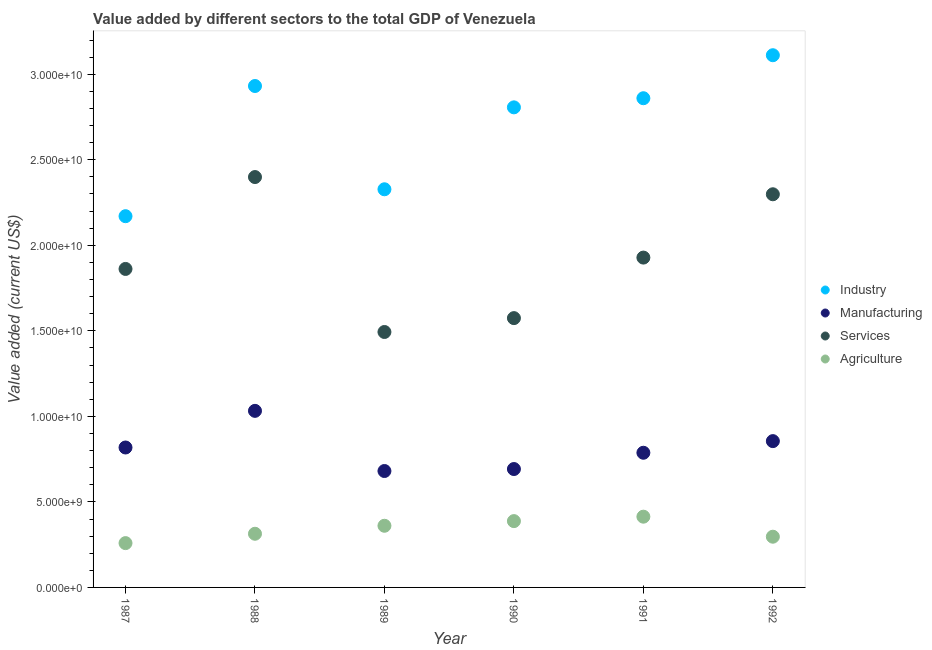How many different coloured dotlines are there?
Keep it short and to the point. 4. Is the number of dotlines equal to the number of legend labels?
Your answer should be very brief. Yes. What is the value added by manufacturing sector in 1992?
Your answer should be very brief. 8.55e+09. Across all years, what is the maximum value added by services sector?
Provide a succinct answer. 2.40e+1. Across all years, what is the minimum value added by industrial sector?
Offer a terse response. 2.17e+1. In which year was the value added by industrial sector maximum?
Ensure brevity in your answer.  1992. In which year was the value added by manufacturing sector minimum?
Keep it short and to the point. 1989. What is the total value added by manufacturing sector in the graph?
Provide a succinct answer. 4.87e+1. What is the difference between the value added by manufacturing sector in 1990 and that in 1992?
Provide a short and direct response. -1.63e+09. What is the difference between the value added by industrial sector in 1989 and the value added by agricultural sector in 1990?
Your answer should be compact. 1.94e+1. What is the average value added by agricultural sector per year?
Offer a terse response. 3.38e+09. In the year 1987, what is the difference between the value added by services sector and value added by agricultural sector?
Provide a succinct answer. 1.60e+1. What is the ratio of the value added by industrial sector in 1989 to that in 1991?
Your answer should be very brief. 0.81. What is the difference between the highest and the second highest value added by agricultural sector?
Provide a succinct answer. 2.59e+08. What is the difference between the highest and the lowest value added by services sector?
Offer a very short reply. 9.06e+09. Is it the case that in every year, the sum of the value added by manufacturing sector and value added by services sector is greater than the sum of value added by agricultural sector and value added by industrial sector?
Make the answer very short. Yes. Is it the case that in every year, the sum of the value added by industrial sector and value added by manufacturing sector is greater than the value added by services sector?
Your answer should be compact. Yes. Does the value added by manufacturing sector monotonically increase over the years?
Offer a terse response. No. Is the value added by services sector strictly greater than the value added by industrial sector over the years?
Keep it short and to the point. No. Are the values on the major ticks of Y-axis written in scientific E-notation?
Give a very brief answer. Yes. Does the graph contain grids?
Give a very brief answer. No. Where does the legend appear in the graph?
Your answer should be very brief. Center right. What is the title of the graph?
Keep it short and to the point. Value added by different sectors to the total GDP of Venezuela. Does "First 20% of population" appear as one of the legend labels in the graph?
Your answer should be compact. No. What is the label or title of the Y-axis?
Offer a very short reply. Value added (current US$). What is the Value added (current US$) in Industry in 1987?
Keep it short and to the point. 2.17e+1. What is the Value added (current US$) in Manufacturing in 1987?
Give a very brief answer. 8.18e+09. What is the Value added (current US$) of Services in 1987?
Your answer should be very brief. 1.86e+1. What is the Value added (current US$) of Agriculture in 1987?
Provide a succinct answer. 2.59e+09. What is the Value added (current US$) of Industry in 1988?
Ensure brevity in your answer.  2.93e+1. What is the Value added (current US$) in Manufacturing in 1988?
Offer a very short reply. 1.03e+1. What is the Value added (current US$) of Services in 1988?
Keep it short and to the point. 2.40e+1. What is the Value added (current US$) in Agriculture in 1988?
Ensure brevity in your answer.  3.14e+09. What is the Value added (current US$) in Industry in 1989?
Offer a very short reply. 2.33e+1. What is the Value added (current US$) in Manufacturing in 1989?
Provide a short and direct response. 6.81e+09. What is the Value added (current US$) in Services in 1989?
Give a very brief answer. 1.49e+1. What is the Value added (current US$) in Agriculture in 1989?
Provide a succinct answer. 3.60e+09. What is the Value added (current US$) in Industry in 1990?
Make the answer very short. 2.81e+1. What is the Value added (current US$) of Manufacturing in 1990?
Offer a very short reply. 6.92e+09. What is the Value added (current US$) in Services in 1990?
Ensure brevity in your answer.  1.57e+1. What is the Value added (current US$) of Agriculture in 1990?
Your answer should be compact. 3.88e+09. What is the Value added (current US$) of Industry in 1991?
Your answer should be compact. 2.86e+1. What is the Value added (current US$) of Manufacturing in 1991?
Provide a short and direct response. 7.87e+09. What is the Value added (current US$) in Services in 1991?
Offer a very short reply. 1.93e+1. What is the Value added (current US$) in Agriculture in 1991?
Provide a short and direct response. 4.14e+09. What is the Value added (current US$) in Industry in 1992?
Your answer should be very brief. 3.11e+1. What is the Value added (current US$) of Manufacturing in 1992?
Offer a very short reply. 8.55e+09. What is the Value added (current US$) in Services in 1992?
Your answer should be very brief. 2.30e+1. What is the Value added (current US$) of Agriculture in 1992?
Your response must be concise. 2.97e+09. Across all years, what is the maximum Value added (current US$) of Industry?
Your answer should be very brief. 3.11e+1. Across all years, what is the maximum Value added (current US$) of Manufacturing?
Your answer should be compact. 1.03e+1. Across all years, what is the maximum Value added (current US$) of Services?
Give a very brief answer. 2.40e+1. Across all years, what is the maximum Value added (current US$) in Agriculture?
Ensure brevity in your answer.  4.14e+09. Across all years, what is the minimum Value added (current US$) in Industry?
Provide a short and direct response. 2.17e+1. Across all years, what is the minimum Value added (current US$) of Manufacturing?
Offer a very short reply. 6.81e+09. Across all years, what is the minimum Value added (current US$) of Services?
Keep it short and to the point. 1.49e+1. Across all years, what is the minimum Value added (current US$) in Agriculture?
Offer a very short reply. 2.59e+09. What is the total Value added (current US$) in Industry in the graph?
Your response must be concise. 1.62e+11. What is the total Value added (current US$) of Manufacturing in the graph?
Your answer should be compact. 4.87e+1. What is the total Value added (current US$) in Services in the graph?
Give a very brief answer. 1.16e+11. What is the total Value added (current US$) of Agriculture in the graph?
Provide a succinct answer. 2.03e+1. What is the difference between the Value added (current US$) in Industry in 1987 and that in 1988?
Provide a short and direct response. -7.61e+09. What is the difference between the Value added (current US$) of Manufacturing in 1987 and that in 1988?
Offer a very short reply. -2.14e+09. What is the difference between the Value added (current US$) of Services in 1987 and that in 1988?
Provide a succinct answer. -5.37e+09. What is the difference between the Value added (current US$) in Agriculture in 1987 and that in 1988?
Your response must be concise. -5.47e+08. What is the difference between the Value added (current US$) of Industry in 1987 and that in 1989?
Your response must be concise. -1.57e+09. What is the difference between the Value added (current US$) in Manufacturing in 1987 and that in 1989?
Ensure brevity in your answer.  1.37e+09. What is the difference between the Value added (current US$) of Services in 1987 and that in 1989?
Provide a short and direct response. 3.69e+09. What is the difference between the Value added (current US$) in Agriculture in 1987 and that in 1989?
Ensure brevity in your answer.  -1.01e+09. What is the difference between the Value added (current US$) of Industry in 1987 and that in 1990?
Make the answer very short. -6.36e+09. What is the difference between the Value added (current US$) of Manufacturing in 1987 and that in 1990?
Offer a very short reply. 1.26e+09. What is the difference between the Value added (current US$) in Services in 1987 and that in 1990?
Provide a succinct answer. 2.87e+09. What is the difference between the Value added (current US$) of Agriculture in 1987 and that in 1990?
Ensure brevity in your answer.  -1.29e+09. What is the difference between the Value added (current US$) in Industry in 1987 and that in 1991?
Offer a very short reply. -6.90e+09. What is the difference between the Value added (current US$) of Manufacturing in 1987 and that in 1991?
Ensure brevity in your answer.  3.08e+08. What is the difference between the Value added (current US$) in Services in 1987 and that in 1991?
Your answer should be very brief. -6.63e+08. What is the difference between the Value added (current US$) in Agriculture in 1987 and that in 1991?
Give a very brief answer. -1.55e+09. What is the difference between the Value added (current US$) in Industry in 1987 and that in 1992?
Your answer should be very brief. -9.41e+09. What is the difference between the Value added (current US$) in Manufacturing in 1987 and that in 1992?
Your response must be concise. -3.73e+08. What is the difference between the Value added (current US$) in Services in 1987 and that in 1992?
Ensure brevity in your answer.  -4.37e+09. What is the difference between the Value added (current US$) in Agriculture in 1987 and that in 1992?
Your response must be concise. -3.75e+08. What is the difference between the Value added (current US$) in Industry in 1988 and that in 1989?
Offer a very short reply. 6.04e+09. What is the difference between the Value added (current US$) in Manufacturing in 1988 and that in 1989?
Your answer should be very brief. 3.52e+09. What is the difference between the Value added (current US$) in Services in 1988 and that in 1989?
Offer a very short reply. 9.06e+09. What is the difference between the Value added (current US$) in Agriculture in 1988 and that in 1989?
Ensure brevity in your answer.  -4.67e+08. What is the difference between the Value added (current US$) in Industry in 1988 and that in 1990?
Your answer should be compact. 1.25e+09. What is the difference between the Value added (current US$) of Manufacturing in 1988 and that in 1990?
Provide a succinct answer. 3.40e+09. What is the difference between the Value added (current US$) of Services in 1988 and that in 1990?
Make the answer very short. 8.25e+09. What is the difference between the Value added (current US$) in Agriculture in 1988 and that in 1990?
Your answer should be very brief. -7.39e+08. What is the difference between the Value added (current US$) of Industry in 1988 and that in 1991?
Keep it short and to the point. 7.14e+08. What is the difference between the Value added (current US$) in Manufacturing in 1988 and that in 1991?
Your answer should be compact. 2.45e+09. What is the difference between the Value added (current US$) of Services in 1988 and that in 1991?
Ensure brevity in your answer.  4.71e+09. What is the difference between the Value added (current US$) of Agriculture in 1988 and that in 1991?
Keep it short and to the point. -9.98e+08. What is the difference between the Value added (current US$) of Industry in 1988 and that in 1992?
Offer a very short reply. -1.80e+09. What is the difference between the Value added (current US$) in Manufacturing in 1988 and that in 1992?
Keep it short and to the point. 1.77e+09. What is the difference between the Value added (current US$) in Services in 1988 and that in 1992?
Offer a terse response. 1.01e+09. What is the difference between the Value added (current US$) of Agriculture in 1988 and that in 1992?
Make the answer very short. 1.72e+08. What is the difference between the Value added (current US$) of Industry in 1989 and that in 1990?
Keep it short and to the point. -4.79e+09. What is the difference between the Value added (current US$) of Manufacturing in 1989 and that in 1990?
Make the answer very short. -1.16e+08. What is the difference between the Value added (current US$) in Services in 1989 and that in 1990?
Provide a succinct answer. -8.11e+08. What is the difference between the Value added (current US$) in Agriculture in 1989 and that in 1990?
Keep it short and to the point. -2.72e+08. What is the difference between the Value added (current US$) of Industry in 1989 and that in 1991?
Offer a very short reply. -5.32e+09. What is the difference between the Value added (current US$) of Manufacturing in 1989 and that in 1991?
Your answer should be compact. -1.07e+09. What is the difference between the Value added (current US$) of Services in 1989 and that in 1991?
Your response must be concise. -4.35e+09. What is the difference between the Value added (current US$) of Agriculture in 1989 and that in 1991?
Give a very brief answer. -5.31e+08. What is the difference between the Value added (current US$) of Industry in 1989 and that in 1992?
Your response must be concise. -7.84e+09. What is the difference between the Value added (current US$) in Manufacturing in 1989 and that in 1992?
Your answer should be very brief. -1.75e+09. What is the difference between the Value added (current US$) of Services in 1989 and that in 1992?
Provide a succinct answer. -8.05e+09. What is the difference between the Value added (current US$) of Agriculture in 1989 and that in 1992?
Make the answer very short. 6.39e+08. What is the difference between the Value added (current US$) in Industry in 1990 and that in 1991?
Your response must be concise. -5.34e+08. What is the difference between the Value added (current US$) in Manufacturing in 1990 and that in 1991?
Keep it short and to the point. -9.51e+08. What is the difference between the Value added (current US$) of Services in 1990 and that in 1991?
Your answer should be very brief. -3.54e+09. What is the difference between the Value added (current US$) of Agriculture in 1990 and that in 1991?
Your response must be concise. -2.59e+08. What is the difference between the Value added (current US$) of Industry in 1990 and that in 1992?
Provide a succinct answer. -3.05e+09. What is the difference between the Value added (current US$) of Manufacturing in 1990 and that in 1992?
Make the answer very short. -1.63e+09. What is the difference between the Value added (current US$) of Services in 1990 and that in 1992?
Make the answer very short. -7.24e+09. What is the difference between the Value added (current US$) of Agriculture in 1990 and that in 1992?
Your answer should be very brief. 9.11e+08. What is the difference between the Value added (current US$) in Industry in 1991 and that in 1992?
Provide a short and direct response. -2.51e+09. What is the difference between the Value added (current US$) in Manufacturing in 1991 and that in 1992?
Give a very brief answer. -6.80e+08. What is the difference between the Value added (current US$) of Services in 1991 and that in 1992?
Your response must be concise. -3.70e+09. What is the difference between the Value added (current US$) of Agriculture in 1991 and that in 1992?
Give a very brief answer. 1.17e+09. What is the difference between the Value added (current US$) in Industry in 1987 and the Value added (current US$) in Manufacturing in 1988?
Make the answer very short. 1.14e+1. What is the difference between the Value added (current US$) in Industry in 1987 and the Value added (current US$) in Services in 1988?
Keep it short and to the point. -2.29e+09. What is the difference between the Value added (current US$) in Industry in 1987 and the Value added (current US$) in Agriculture in 1988?
Your response must be concise. 1.86e+1. What is the difference between the Value added (current US$) of Manufacturing in 1987 and the Value added (current US$) of Services in 1988?
Make the answer very short. -1.58e+1. What is the difference between the Value added (current US$) in Manufacturing in 1987 and the Value added (current US$) in Agriculture in 1988?
Provide a succinct answer. 5.04e+09. What is the difference between the Value added (current US$) in Services in 1987 and the Value added (current US$) in Agriculture in 1988?
Ensure brevity in your answer.  1.55e+1. What is the difference between the Value added (current US$) in Industry in 1987 and the Value added (current US$) in Manufacturing in 1989?
Offer a very short reply. 1.49e+1. What is the difference between the Value added (current US$) of Industry in 1987 and the Value added (current US$) of Services in 1989?
Keep it short and to the point. 6.77e+09. What is the difference between the Value added (current US$) in Industry in 1987 and the Value added (current US$) in Agriculture in 1989?
Ensure brevity in your answer.  1.81e+1. What is the difference between the Value added (current US$) in Manufacturing in 1987 and the Value added (current US$) in Services in 1989?
Make the answer very short. -6.75e+09. What is the difference between the Value added (current US$) of Manufacturing in 1987 and the Value added (current US$) of Agriculture in 1989?
Your answer should be compact. 4.58e+09. What is the difference between the Value added (current US$) in Services in 1987 and the Value added (current US$) in Agriculture in 1989?
Provide a short and direct response. 1.50e+1. What is the difference between the Value added (current US$) of Industry in 1987 and the Value added (current US$) of Manufacturing in 1990?
Your answer should be compact. 1.48e+1. What is the difference between the Value added (current US$) in Industry in 1987 and the Value added (current US$) in Services in 1990?
Keep it short and to the point. 5.96e+09. What is the difference between the Value added (current US$) of Industry in 1987 and the Value added (current US$) of Agriculture in 1990?
Make the answer very short. 1.78e+1. What is the difference between the Value added (current US$) in Manufacturing in 1987 and the Value added (current US$) in Services in 1990?
Keep it short and to the point. -7.56e+09. What is the difference between the Value added (current US$) in Manufacturing in 1987 and the Value added (current US$) in Agriculture in 1990?
Give a very brief answer. 4.30e+09. What is the difference between the Value added (current US$) in Services in 1987 and the Value added (current US$) in Agriculture in 1990?
Provide a succinct answer. 1.47e+1. What is the difference between the Value added (current US$) in Industry in 1987 and the Value added (current US$) in Manufacturing in 1991?
Offer a very short reply. 1.38e+1. What is the difference between the Value added (current US$) in Industry in 1987 and the Value added (current US$) in Services in 1991?
Provide a succinct answer. 2.42e+09. What is the difference between the Value added (current US$) in Industry in 1987 and the Value added (current US$) in Agriculture in 1991?
Keep it short and to the point. 1.76e+1. What is the difference between the Value added (current US$) in Manufacturing in 1987 and the Value added (current US$) in Services in 1991?
Your answer should be compact. -1.11e+1. What is the difference between the Value added (current US$) in Manufacturing in 1987 and the Value added (current US$) in Agriculture in 1991?
Provide a short and direct response. 4.04e+09. What is the difference between the Value added (current US$) in Services in 1987 and the Value added (current US$) in Agriculture in 1991?
Keep it short and to the point. 1.45e+1. What is the difference between the Value added (current US$) in Industry in 1987 and the Value added (current US$) in Manufacturing in 1992?
Give a very brief answer. 1.31e+1. What is the difference between the Value added (current US$) of Industry in 1987 and the Value added (current US$) of Services in 1992?
Your answer should be compact. -1.28e+09. What is the difference between the Value added (current US$) of Industry in 1987 and the Value added (current US$) of Agriculture in 1992?
Your answer should be compact. 1.87e+1. What is the difference between the Value added (current US$) in Manufacturing in 1987 and the Value added (current US$) in Services in 1992?
Your answer should be compact. -1.48e+1. What is the difference between the Value added (current US$) of Manufacturing in 1987 and the Value added (current US$) of Agriculture in 1992?
Offer a terse response. 5.21e+09. What is the difference between the Value added (current US$) of Services in 1987 and the Value added (current US$) of Agriculture in 1992?
Provide a short and direct response. 1.57e+1. What is the difference between the Value added (current US$) in Industry in 1988 and the Value added (current US$) in Manufacturing in 1989?
Keep it short and to the point. 2.25e+1. What is the difference between the Value added (current US$) in Industry in 1988 and the Value added (current US$) in Services in 1989?
Your response must be concise. 1.44e+1. What is the difference between the Value added (current US$) in Industry in 1988 and the Value added (current US$) in Agriculture in 1989?
Offer a very short reply. 2.57e+1. What is the difference between the Value added (current US$) in Manufacturing in 1988 and the Value added (current US$) in Services in 1989?
Your answer should be compact. -4.61e+09. What is the difference between the Value added (current US$) in Manufacturing in 1988 and the Value added (current US$) in Agriculture in 1989?
Your answer should be very brief. 6.72e+09. What is the difference between the Value added (current US$) in Services in 1988 and the Value added (current US$) in Agriculture in 1989?
Provide a succinct answer. 2.04e+1. What is the difference between the Value added (current US$) of Industry in 1988 and the Value added (current US$) of Manufacturing in 1990?
Make the answer very short. 2.24e+1. What is the difference between the Value added (current US$) in Industry in 1988 and the Value added (current US$) in Services in 1990?
Make the answer very short. 1.36e+1. What is the difference between the Value added (current US$) in Industry in 1988 and the Value added (current US$) in Agriculture in 1990?
Give a very brief answer. 2.54e+1. What is the difference between the Value added (current US$) of Manufacturing in 1988 and the Value added (current US$) of Services in 1990?
Provide a succinct answer. -5.42e+09. What is the difference between the Value added (current US$) in Manufacturing in 1988 and the Value added (current US$) in Agriculture in 1990?
Offer a very short reply. 6.45e+09. What is the difference between the Value added (current US$) in Services in 1988 and the Value added (current US$) in Agriculture in 1990?
Offer a very short reply. 2.01e+1. What is the difference between the Value added (current US$) in Industry in 1988 and the Value added (current US$) in Manufacturing in 1991?
Your answer should be very brief. 2.14e+1. What is the difference between the Value added (current US$) of Industry in 1988 and the Value added (current US$) of Services in 1991?
Provide a succinct answer. 1.00e+1. What is the difference between the Value added (current US$) of Industry in 1988 and the Value added (current US$) of Agriculture in 1991?
Your answer should be very brief. 2.52e+1. What is the difference between the Value added (current US$) of Manufacturing in 1988 and the Value added (current US$) of Services in 1991?
Offer a terse response. -8.96e+09. What is the difference between the Value added (current US$) of Manufacturing in 1988 and the Value added (current US$) of Agriculture in 1991?
Keep it short and to the point. 6.19e+09. What is the difference between the Value added (current US$) in Services in 1988 and the Value added (current US$) in Agriculture in 1991?
Your answer should be compact. 1.99e+1. What is the difference between the Value added (current US$) in Industry in 1988 and the Value added (current US$) in Manufacturing in 1992?
Offer a very short reply. 2.08e+1. What is the difference between the Value added (current US$) in Industry in 1988 and the Value added (current US$) in Services in 1992?
Make the answer very short. 6.33e+09. What is the difference between the Value added (current US$) of Industry in 1988 and the Value added (current US$) of Agriculture in 1992?
Your answer should be very brief. 2.63e+1. What is the difference between the Value added (current US$) in Manufacturing in 1988 and the Value added (current US$) in Services in 1992?
Ensure brevity in your answer.  -1.27e+1. What is the difference between the Value added (current US$) of Manufacturing in 1988 and the Value added (current US$) of Agriculture in 1992?
Provide a short and direct response. 7.36e+09. What is the difference between the Value added (current US$) of Services in 1988 and the Value added (current US$) of Agriculture in 1992?
Provide a succinct answer. 2.10e+1. What is the difference between the Value added (current US$) in Industry in 1989 and the Value added (current US$) in Manufacturing in 1990?
Give a very brief answer. 1.64e+1. What is the difference between the Value added (current US$) of Industry in 1989 and the Value added (current US$) of Services in 1990?
Ensure brevity in your answer.  7.53e+09. What is the difference between the Value added (current US$) in Industry in 1989 and the Value added (current US$) in Agriculture in 1990?
Provide a succinct answer. 1.94e+1. What is the difference between the Value added (current US$) of Manufacturing in 1989 and the Value added (current US$) of Services in 1990?
Offer a terse response. -8.94e+09. What is the difference between the Value added (current US$) in Manufacturing in 1989 and the Value added (current US$) in Agriculture in 1990?
Give a very brief answer. 2.93e+09. What is the difference between the Value added (current US$) of Services in 1989 and the Value added (current US$) of Agriculture in 1990?
Provide a succinct answer. 1.11e+1. What is the difference between the Value added (current US$) in Industry in 1989 and the Value added (current US$) in Manufacturing in 1991?
Your answer should be very brief. 1.54e+1. What is the difference between the Value added (current US$) of Industry in 1989 and the Value added (current US$) of Services in 1991?
Your response must be concise. 3.99e+09. What is the difference between the Value added (current US$) in Industry in 1989 and the Value added (current US$) in Agriculture in 1991?
Your answer should be compact. 1.91e+1. What is the difference between the Value added (current US$) in Manufacturing in 1989 and the Value added (current US$) in Services in 1991?
Ensure brevity in your answer.  -1.25e+1. What is the difference between the Value added (current US$) of Manufacturing in 1989 and the Value added (current US$) of Agriculture in 1991?
Make the answer very short. 2.67e+09. What is the difference between the Value added (current US$) in Services in 1989 and the Value added (current US$) in Agriculture in 1991?
Give a very brief answer. 1.08e+1. What is the difference between the Value added (current US$) of Industry in 1989 and the Value added (current US$) of Manufacturing in 1992?
Ensure brevity in your answer.  1.47e+1. What is the difference between the Value added (current US$) in Industry in 1989 and the Value added (current US$) in Services in 1992?
Your answer should be very brief. 2.92e+08. What is the difference between the Value added (current US$) in Industry in 1989 and the Value added (current US$) in Agriculture in 1992?
Ensure brevity in your answer.  2.03e+1. What is the difference between the Value added (current US$) in Manufacturing in 1989 and the Value added (current US$) in Services in 1992?
Provide a short and direct response. -1.62e+1. What is the difference between the Value added (current US$) in Manufacturing in 1989 and the Value added (current US$) in Agriculture in 1992?
Provide a short and direct response. 3.84e+09. What is the difference between the Value added (current US$) in Services in 1989 and the Value added (current US$) in Agriculture in 1992?
Offer a terse response. 1.20e+1. What is the difference between the Value added (current US$) in Industry in 1990 and the Value added (current US$) in Manufacturing in 1991?
Ensure brevity in your answer.  2.02e+1. What is the difference between the Value added (current US$) in Industry in 1990 and the Value added (current US$) in Services in 1991?
Ensure brevity in your answer.  8.78e+09. What is the difference between the Value added (current US$) in Industry in 1990 and the Value added (current US$) in Agriculture in 1991?
Keep it short and to the point. 2.39e+1. What is the difference between the Value added (current US$) in Manufacturing in 1990 and the Value added (current US$) in Services in 1991?
Give a very brief answer. -1.24e+1. What is the difference between the Value added (current US$) of Manufacturing in 1990 and the Value added (current US$) of Agriculture in 1991?
Offer a very short reply. 2.79e+09. What is the difference between the Value added (current US$) in Services in 1990 and the Value added (current US$) in Agriculture in 1991?
Offer a terse response. 1.16e+1. What is the difference between the Value added (current US$) in Industry in 1990 and the Value added (current US$) in Manufacturing in 1992?
Your response must be concise. 1.95e+1. What is the difference between the Value added (current US$) of Industry in 1990 and the Value added (current US$) of Services in 1992?
Offer a very short reply. 5.08e+09. What is the difference between the Value added (current US$) of Industry in 1990 and the Value added (current US$) of Agriculture in 1992?
Your answer should be compact. 2.51e+1. What is the difference between the Value added (current US$) in Manufacturing in 1990 and the Value added (current US$) in Services in 1992?
Your response must be concise. -1.61e+1. What is the difference between the Value added (current US$) of Manufacturing in 1990 and the Value added (current US$) of Agriculture in 1992?
Make the answer very short. 3.96e+09. What is the difference between the Value added (current US$) of Services in 1990 and the Value added (current US$) of Agriculture in 1992?
Make the answer very short. 1.28e+1. What is the difference between the Value added (current US$) in Industry in 1991 and the Value added (current US$) in Manufacturing in 1992?
Your response must be concise. 2.00e+1. What is the difference between the Value added (current US$) of Industry in 1991 and the Value added (current US$) of Services in 1992?
Make the answer very short. 5.61e+09. What is the difference between the Value added (current US$) of Industry in 1991 and the Value added (current US$) of Agriculture in 1992?
Offer a very short reply. 2.56e+1. What is the difference between the Value added (current US$) in Manufacturing in 1991 and the Value added (current US$) in Services in 1992?
Your answer should be compact. -1.51e+1. What is the difference between the Value added (current US$) in Manufacturing in 1991 and the Value added (current US$) in Agriculture in 1992?
Your answer should be very brief. 4.91e+09. What is the difference between the Value added (current US$) in Services in 1991 and the Value added (current US$) in Agriculture in 1992?
Give a very brief answer. 1.63e+1. What is the average Value added (current US$) in Industry per year?
Provide a short and direct response. 2.70e+1. What is the average Value added (current US$) of Manufacturing per year?
Ensure brevity in your answer.  8.11e+09. What is the average Value added (current US$) in Services per year?
Offer a terse response. 1.93e+1. What is the average Value added (current US$) of Agriculture per year?
Offer a terse response. 3.38e+09. In the year 1987, what is the difference between the Value added (current US$) of Industry and Value added (current US$) of Manufacturing?
Make the answer very short. 1.35e+1. In the year 1987, what is the difference between the Value added (current US$) of Industry and Value added (current US$) of Services?
Ensure brevity in your answer.  3.08e+09. In the year 1987, what is the difference between the Value added (current US$) of Industry and Value added (current US$) of Agriculture?
Offer a terse response. 1.91e+1. In the year 1987, what is the difference between the Value added (current US$) in Manufacturing and Value added (current US$) in Services?
Ensure brevity in your answer.  -1.04e+1. In the year 1987, what is the difference between the Value added (current US$) of Manufacturing and Value added (current US$) of Agriculture?
Keep it short and to the point. 5.59e+09. In the year 1987, what is the difference between the Value added (current US$) of Services and Value added (current US$) of Agriculture?
Provide a succinct answer. 1.60e+1. In the year 1988, what is the difference between the Value added (current US$) of Industry and Value added (current US$) of Manufacturing?
Your answer should be very brief. 1.90e+1. In the year 1988, what is the difference between the Value added (current US$) of Industry and Value added (current US$) of Services?
Offer a very short reply. 5.32e+09. In the year 1988, what is the difference between the Value added (current US$) in Industry and Value added (current US$) in Agriculture?
Provide a short and direct response. 2.62e+1. In the year 1988, what is the difference between the Value added (current US$) in Manufacturing and Value added (current US$) in Services?
Provide a succinct answer. -1.37e+1. In the year 1988, what is the difference between the Value added (current US$) of Manufacturing and Value added (current US$) of Agriculture?
Ensure brevity in your answer.  7.18e+09. In the year 1988, what is the difference between the Value added (current US$) of Services and Value added (current US$) of Agriculture?
Offer a terse response. 2.09e+1. In the year 1989, what is the difference between the Value added (current US$) in Industry and Value added (current US$) in Manufacturing?
Your answer should be compact. 1.65e+1. In the year 1989, what is the difference between the Value added (current US$) of Industry and Value added (current US$) of Services?
Keep it short and to the point. 8.34e+09. In the year 1989, what is the difference between the Value added (current US$) of Industry and Value added (current US$) of Agriculture?
Provide a short and direct response. 1.97e+1. In the year 1989, what is the difference between the Value added (current US$) of Manufacturing and Value added (current US$) of Services?
Your answer should be compact. -8.13e+09. In the year 1989, what is the difference between the Value added (current US$) of Manufacturing and Value added (current US$) of Agriculture?
Provide a short and direct response. 3.20e+09. In the year 1989, what is the difference between the Value added (current US$) in Services and Value added (current US$) in Agriculture?
Your response must be concise. 1.13e+1. In the year 1990, what is the difference between the Value added (current US$) of Industry and Value added (current US$) of Manufacturing?
Offer a terse response. 2.11e+1. In the year 1990, what is the difference between the Value added (current US$) of Industry and Value added (current US$) of Services?
Give a very brief answer. 1.23e+1. In the year 1990, what is the difference between the Value added (current US$) in Industry and Value added (current US$) in Agriculture?
Make the answer very short. 2.42e+1. In the year 1990, what is the difference between the Value added (current US$) of Manufacturing and Value added (current US$) of Services?
Offer a terse response. -8.82e+09. In the year 1990, what is the difference between the Value added (current US$) in Manufacturing and Value added (current US$) in Agriculture?
Ensure brevity in your answer.  3.04e+09. In the year 1990, what is the difference between the Value added (current US$) of Services and Value added (current US$) of Agriculture?
Provide a succinct answer. 1.19e+1. In the year 1991, what is the difference between the Value added (current US$) in Industry and Value added (current US$) in Manufacturing?
Ensure brevity in your answer.  2.07e+1. In the year 1991, what is the difference between the Value added (current US$) in Industry and Value added (current US$) in Services?
Provide a short and direct response. 9.32e+09. In the year 1991, what is the difference between the Value added (current US$) of Industry and Value added (current US$) of Agriculture?
Provide a succinct answer. 2.45e+1. In the year 1991, what is the difference between the Value added (current US$) in Manufacturing and Value added (current US$) in Services?
Keep it short and to the point. -1.14e+1. In the year 1991, what is the difference between the Value added (current US$) in Manufacturing and Value added (current US$) in Agriculture?
Offer a terse response. 3.74e+09. In the year 1991, what is the difference between the Value added (current US$) in Services and Value added (current US$) in Agriculture?
Offer a terse response. 1.51e+1. In the year 1992, what is the difference between the Value added (current US$) in Industry and Value added (current US$) in Manufacturing?
Your response must be concise. 2.26e+1. In the year 1992, what is the difference between the Value added (current US$) of Industry and Value added (current US$) of Services?
Your response must be concise. 8.13e+09. In the year 1992, what is the difference between the Value added (current US$) of Industry and Value added (current US$) of Agriculture?
Your answer should be compact. 2.81e+1. In the year 1992, what is the difference between the Value added (current US$) of Manufacturing and Value added (current US$) of Services?
Provide a short and direct response. -1.44e+1. In the year 1992, what is the difference between the Value added (current US$) of Manufacturing and Value added (current US$) of Agriculture?
Provide a short and direct response. 5.59e+09. In the year 1992, what is the difference between the Value added (current US$) in Services and Value added (current US$) in Agriculture?
Offer a very short reply. 2.00e+1. What is the ratio of the Value added (current US$) of Industry in 1987 to that in 1988?
Your answer should be very brief. 0.74. What is the ratio of the Value added (current US$) of Manufacturing in 1987 to that in 1988?
Keep it short and to the point. 0.79. What is the ratio of the Value added (current US$) of Services in 1987 to that in 1988?
Your response must be concise. 0.78. What is the ratio of the Value added (current US$) in Agriculture in 1987 to that in 1988?
Make the answer very short. 0.83. What is the ratio of the Value added (current US$) of Industry in 1987 to that in 1989?
Your response must be concise. 0.93. What is the ratio of the Value added (current US$) of Manufacturing in 1987 to that in 1989?
Your answer should be very brief. 1.2. What is the ratio of the Value added (current US$) in Services in 1987 to that in 1989?
Provide a short and direct response. 1.25. What is the ratio of the Value added (current US$) in Agriculture in 1987 to that in 1989?
Your response must be concise. 0.72. What is the ratio of the Value added (current US$) of Industry in 1987 to that in 1990?
Offer a terse response. 0.77. What is the ratio of the Value added (current US$) in Manufacturing in 1987 to that in 1990?
Offer a very short reply. 1.18. What is the ratio of the Value added (current US$) in Services in 1987 to that in 1990?
Make the answer very short. 1.18. What is the ratio of the Value added (current US$) of Agriculture in 1987 to that in 1990?
Make the answer very short. 0.67. What is the ratio of the Value added (current US$) in Industry in 1987 to that in 1991?
Offer a very short reply. 0.76. What is the ratio of the Value added (current US$) in Manufacturing in 1987 to that in 1991?
Your answer should be very brief. 1.04. What is the ratio of the Value added (current US$) of Services in 1987 to that in 1991?
Ensure brevity in your answer.  0.97. What is the ratio of the Value added (current US$) in Agriculture in 1987 to that in 1991?
Ensure brevity in your answer.  0.63. What is the ratio of the Value added (current US$) in Industry in 1987 to that in 1992?
Offer a terse response. 0.7. What is the ratio of the Value added (current US$) in Manufacturing in 1987 to that in 1992?
Your answer should be compact. 0.96. What is the ratio of the Value added (current US$) of Services in 1987 to that in 1992?
Ensure brevity in your answer.  0.81. What is the ratio of the Value added (current US$) of Agriculture in 1987 to that in 1992?
Your response must be concise. 0.87. What is the ratio of the Value added (current US$) of Industry in 1988 to that in 1989?
Give a very brief answer. 1.26. What is the ratio of the Value added (current US$) of Manufacturing in 1988 to that in 1989?
Provide a succinct answer. 1.52. What is the ratio of the Value added (current US$) of Services in 1988 to that in 1989?
Your answer should be compact. 1.61. What is the ratio of the Value added (current US$) of Agriculture in 1988 to that in 1989?
Offer a terse response. 0.87. What is the ratio of the Value added (current US$) in Industry in 1988 to that in 1990?
Make the answer very short. 1.04. What is the ratio of the Value added (current US$) in Manufacturing in 1988 to that in 1990?
Your answer should be compact. 1.49. What is the ratio of the Value added (current US$) of Services in 1988 to that in 1990?
Give a very brief answer. 1.52. What is the ratio of the Value added (current US$) of Agriculture in 1988 to that in 1990?
Provide a succinct answer. 0.81. What is the ratio of the Value added (current US$) of Manufacturing in 1988 to that in 1991?
Provide a short and direct response. 1.31. What is the ratio of the Value added (current US$) of Services in 1988 to that in 1991?
Your answer should be very brief. 1.24. What is the ratio of the Value added (current US$) in Agriculture in 1988 to that in 1991?
Your response must be concise. 0.76. What is the ratio of the Value added (current US$) in Industry in 1988 to that in 1992?
Your response must be concise. 0.94. What is the ratio of the Value added (current US$) of Manufacturing in 1988 to that in 1992?
Ensure brevity in your answer.  1.21. What is the ratio of the Value added (current US$) in Services in 1988 to that in 1992?
Give a very brief answer. 1.04. What is the ratio of the Value added (current US$) of Agriculture in 1988 to that in 1992?
Ensure brevity in your answer.  1.06. What is the ratio of the Value added (current US$) of Industry in 1989 to that in 1990?
Provide a short and direct response. 0.83. What is the ratio of the Value added (current US$) of Manufacturing in 1989 to that in 1990?
Your answer should be very brief. 0.98. What is the ratio of the Value added (current US$) of Services in 1989 to that in 1990?
Make the answer very short. 0.95. What is the ratio of the Value added (current US$) in Agriculture in 1989 to that in 1990?
Give a very brief answer. 0.93. What is the ratio of the Value added (current US$) of Industry in 1989 to that in 1991?
Offer a terse response. 0.81. What is the ratio of the Value added (current US$) in Manufacturing in 1989 to that in 1991?
Give a very brief answer. 0.86. What is the ratio of the Value added (current US$) of Services in 1989 to that in 1991?
Provide a succinct answer. 0.77. What is the ratio of the Value added (current US$) in Agriculture in 1989 to that in 1991?
Make the answer very short. 0.87. What is the ratio of the Value added (current US$) in Industry in 1989 to that in 1992?
Provide a short and direct response. 0.75. What is the ratio of the Value added (current US$) in Manufacturing in 1989 to that in 1992?
Your answer should be compact. 0.8. What is the ratio of the Value added (current US$) in Services in 1989 to that in 1992?
Your answer should be compact. 0.65. What is the ratio of the Value added (current US$) of Agriculture in 1989 to that in 1992?
Your response must be concise. 1.22. What is the ratio of the Value added (current US$) in Industry in 1990 to that in 1991?
Ensure brevity in your answer.  0.98. What is the ratio of the Value added (current US$) of Manufacturing in 1990 to that in 1991?
Provide a short and direct response. 0.88. What is the ratio of the Value added (current US$) in Services in 1990 to that in 1991?
Provide a short and direct response. 0.82. What is the ratio of the Value added (current US$) in Agriculture in 1990 to that in 1991?
Give a very brief answer. 0.94. What is the ratio of the Value added (current US$) in Industry in 1990 to that in 1992?
Ensure brevity in your answer.  0.9. What is the ratio of the Value added (current US$) in Manufacturing in 1990 to that in 1992?
Keep it short and to the point. 0.81. What is the ratio of the Value added (current US$) of Services in 1990 to that in 1992?
Offer a terse response. 0.69. What is the ratio of the Value added (current US$) in Agriculture in 1990 to that in 1992?
Provide a short and direct response. 1.31. What is the ratio of the Value added (current US$) in Industry in 1991 to that in 1992?
Give a very brief answer. 0.92. What is the ratio of the Value added (current US$) in Manufacturing in 1991 to that in 1992?
Offer a terse response. 0.92. What is the ratio of the Value added (current US$) in Services in 1991 to that in 1992?
Provide a short and direct response. 0.84. What is the ratio of the Value added (current US$) in Agriculture in 1991 to that in 1992?
Provide a succinct answer. 1.39. What is the difference between the highest and the second highest Value added (current US$) of Industry?
Your answer should be very brief. 1.80e+09. What is the difference between the highest and the second highest Value added (current US$) of Manufacturing?
Provide a succinct answer. 1.77e+09. What is the difference between the highest and the second highest Value added (current US$) of Services?
Keep it short and to the point. 1.01e+09. What is the difference between the highest and the second highest Value added (current US$) of Agriculture?
Your answer should be very brief. 2.59e+08. What is the difference between the highest and the lowest Value added (current US$) of Industry?
Your answer should be very brief. 9.41e+09. What is the difference between the highest and the lowest Value added (current US$) of Manufacturing?
Offer a very short reply. 3.52e+09. What is the difference between the highest and the lowest Value added (current US$) of Services?
Keep it short and to the point. 9.06e+09. What is the difference between the highest and the lowest Value added (current US$) in Agriculture?
Your answer should be very brief. 1.55e+09. 